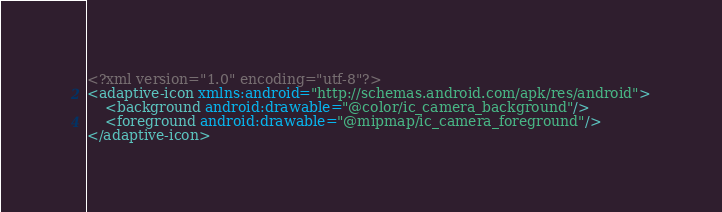Convert code to text. <code><loc_0><loc_0><loc_500><loc_500><_XML_><?xml version="1.0" encoding="utf-8"?>
<adaptive-icon xmlns:android="http://schemas.android.com/apk/res/android">
    <background android:drawable="@color/ic_camera_background"/>
    <foreground android:drawable="@mipmap/ic_camera_foreground"/>
</adaptive-icon></code> 